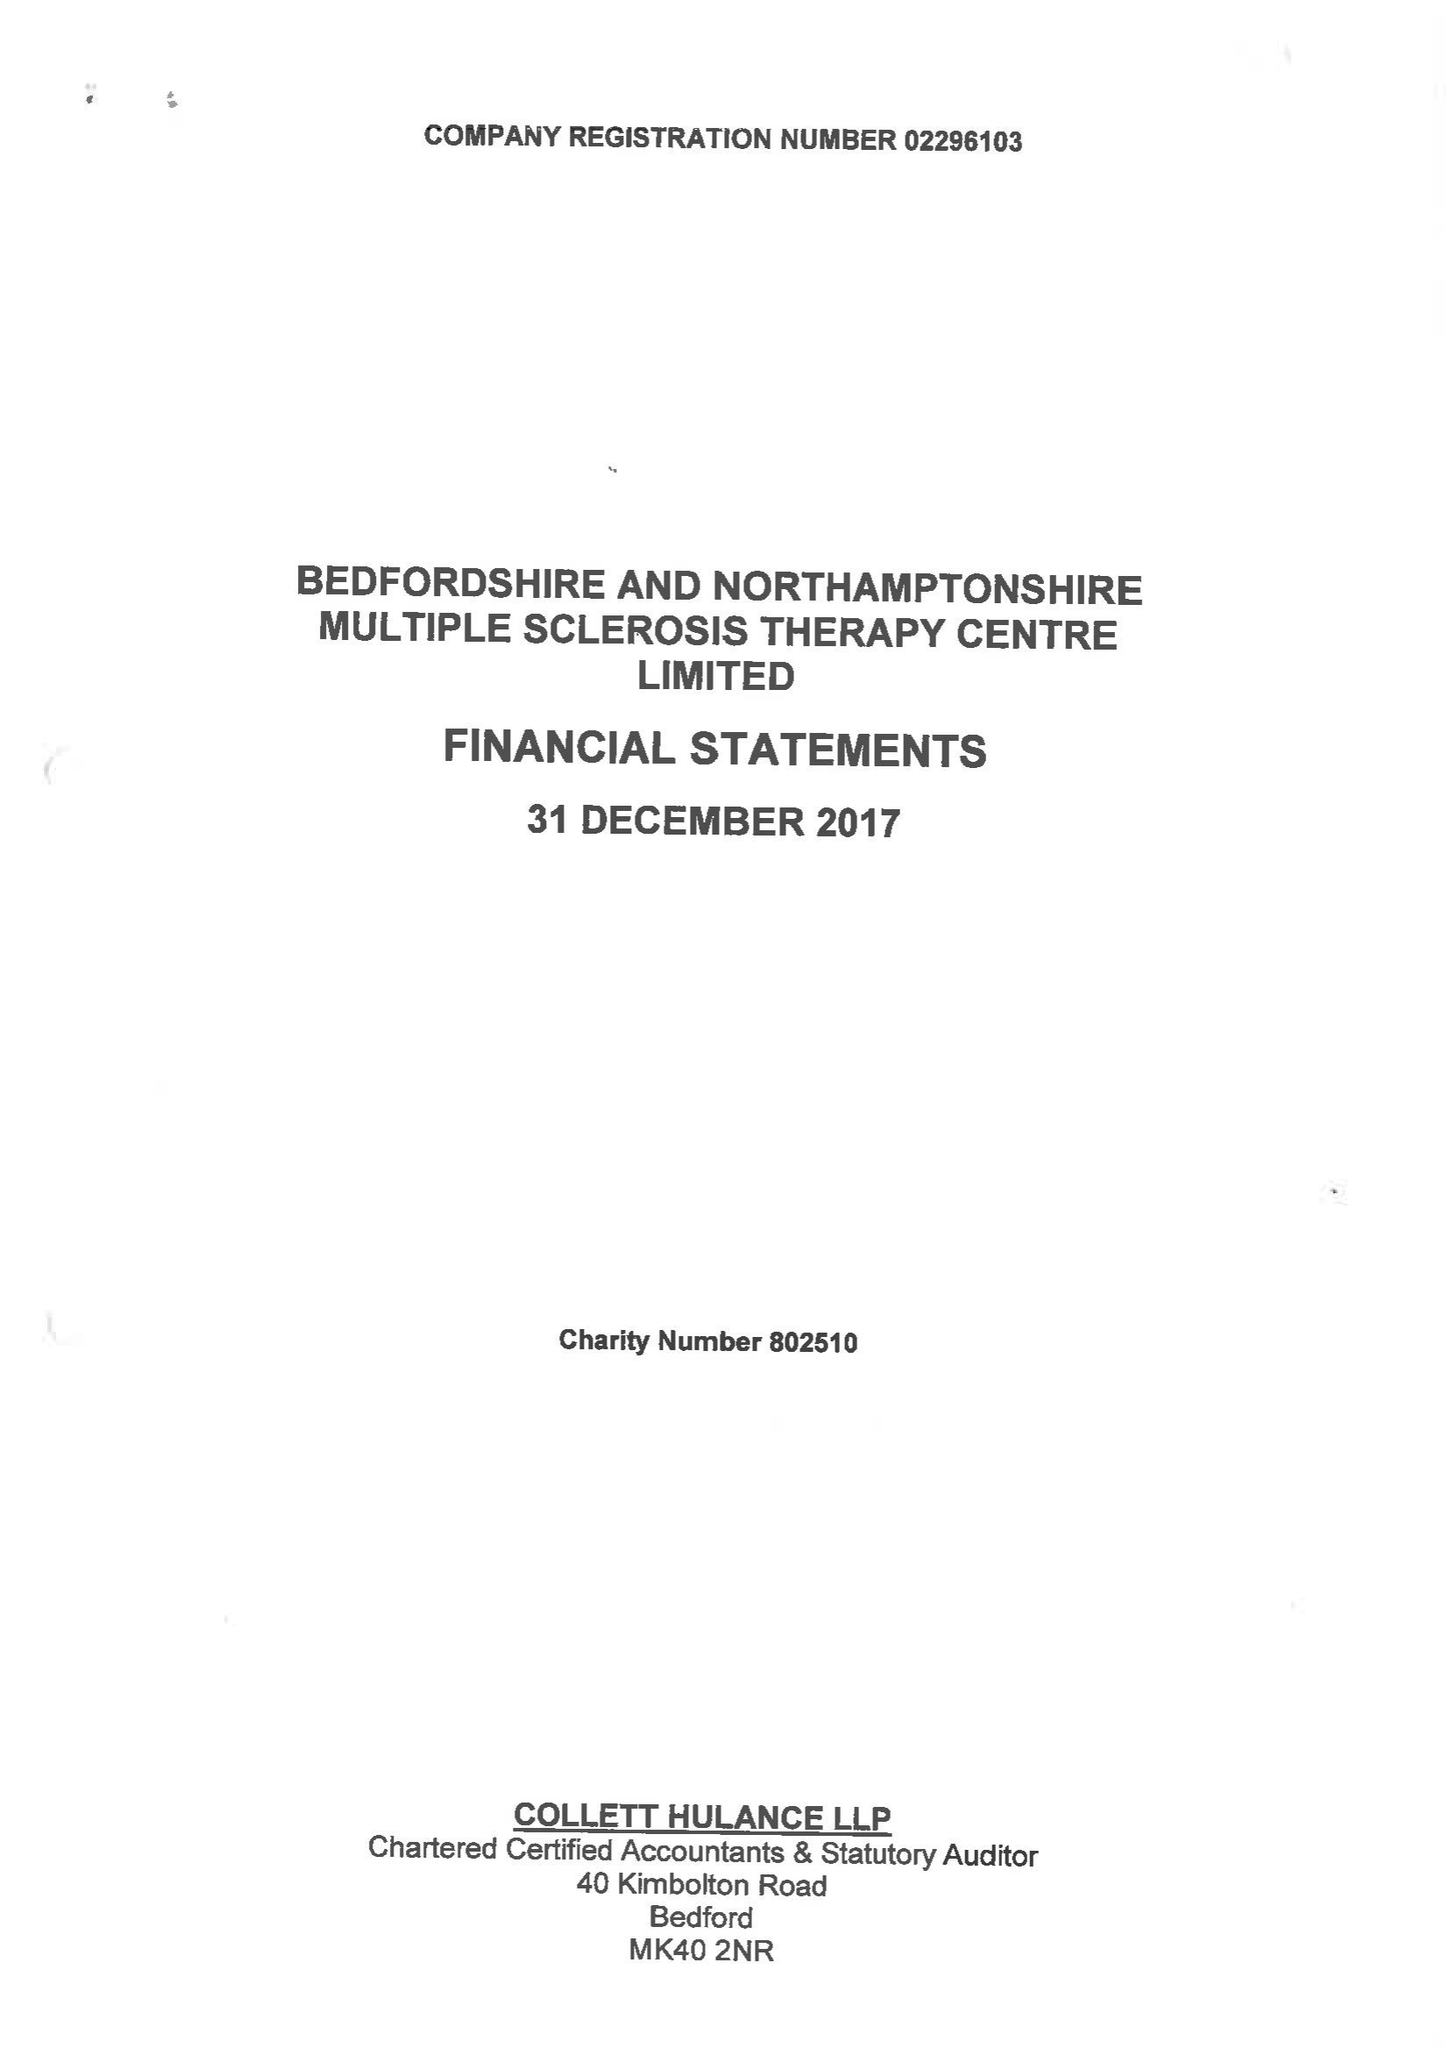What is the value for the address__postcode?
Answer the question using a single word or phrase. MK41 9RX 